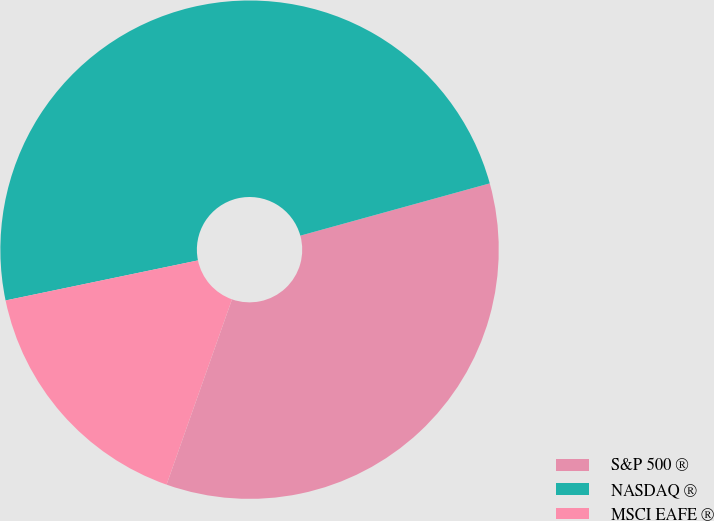<chart> <loc_0><loc_0><loc_500><loc_500><pie_chart><fcel>S&P 500 ®<fcel>NASDAQ ®<fcel>MSCI EAFE ®<nl><fcel>34.69%<fcel>48.98%<fcel>16.33%<nl></chart> 